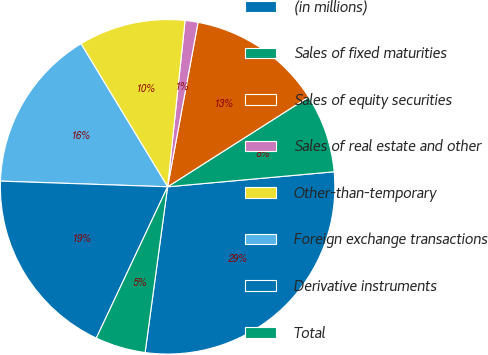Convert chart. <chart><loc_0><loc_0><loc_500><loc_500><pie_chart><fcel>(in millions)<fcel>Sales of fixed maturities<fcel>Sales of equity securities<fcel>Sales of real estate and other<fcel>Other-than-temporary<fcel>Foreign exchange transactions<fcel>Derivative instruments<fcel>Total<nl><fcel>28.58%<fcel>7.59%<fcel>13.06%<fcel>1.25%<fcel>10.33%<fcel>15.79%<fcel>18.53%<fcel>4.86%<nl></chart> 